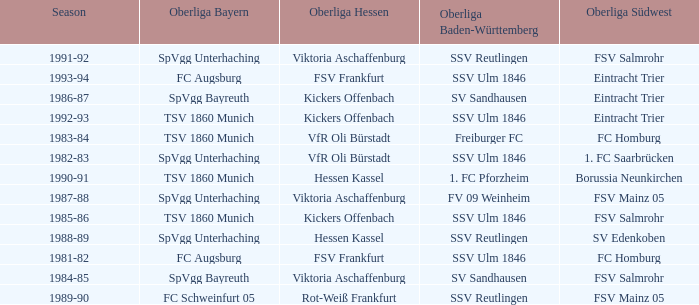Which Oberliga Bayern has a Season of 1981-82? FC Augsburg. 